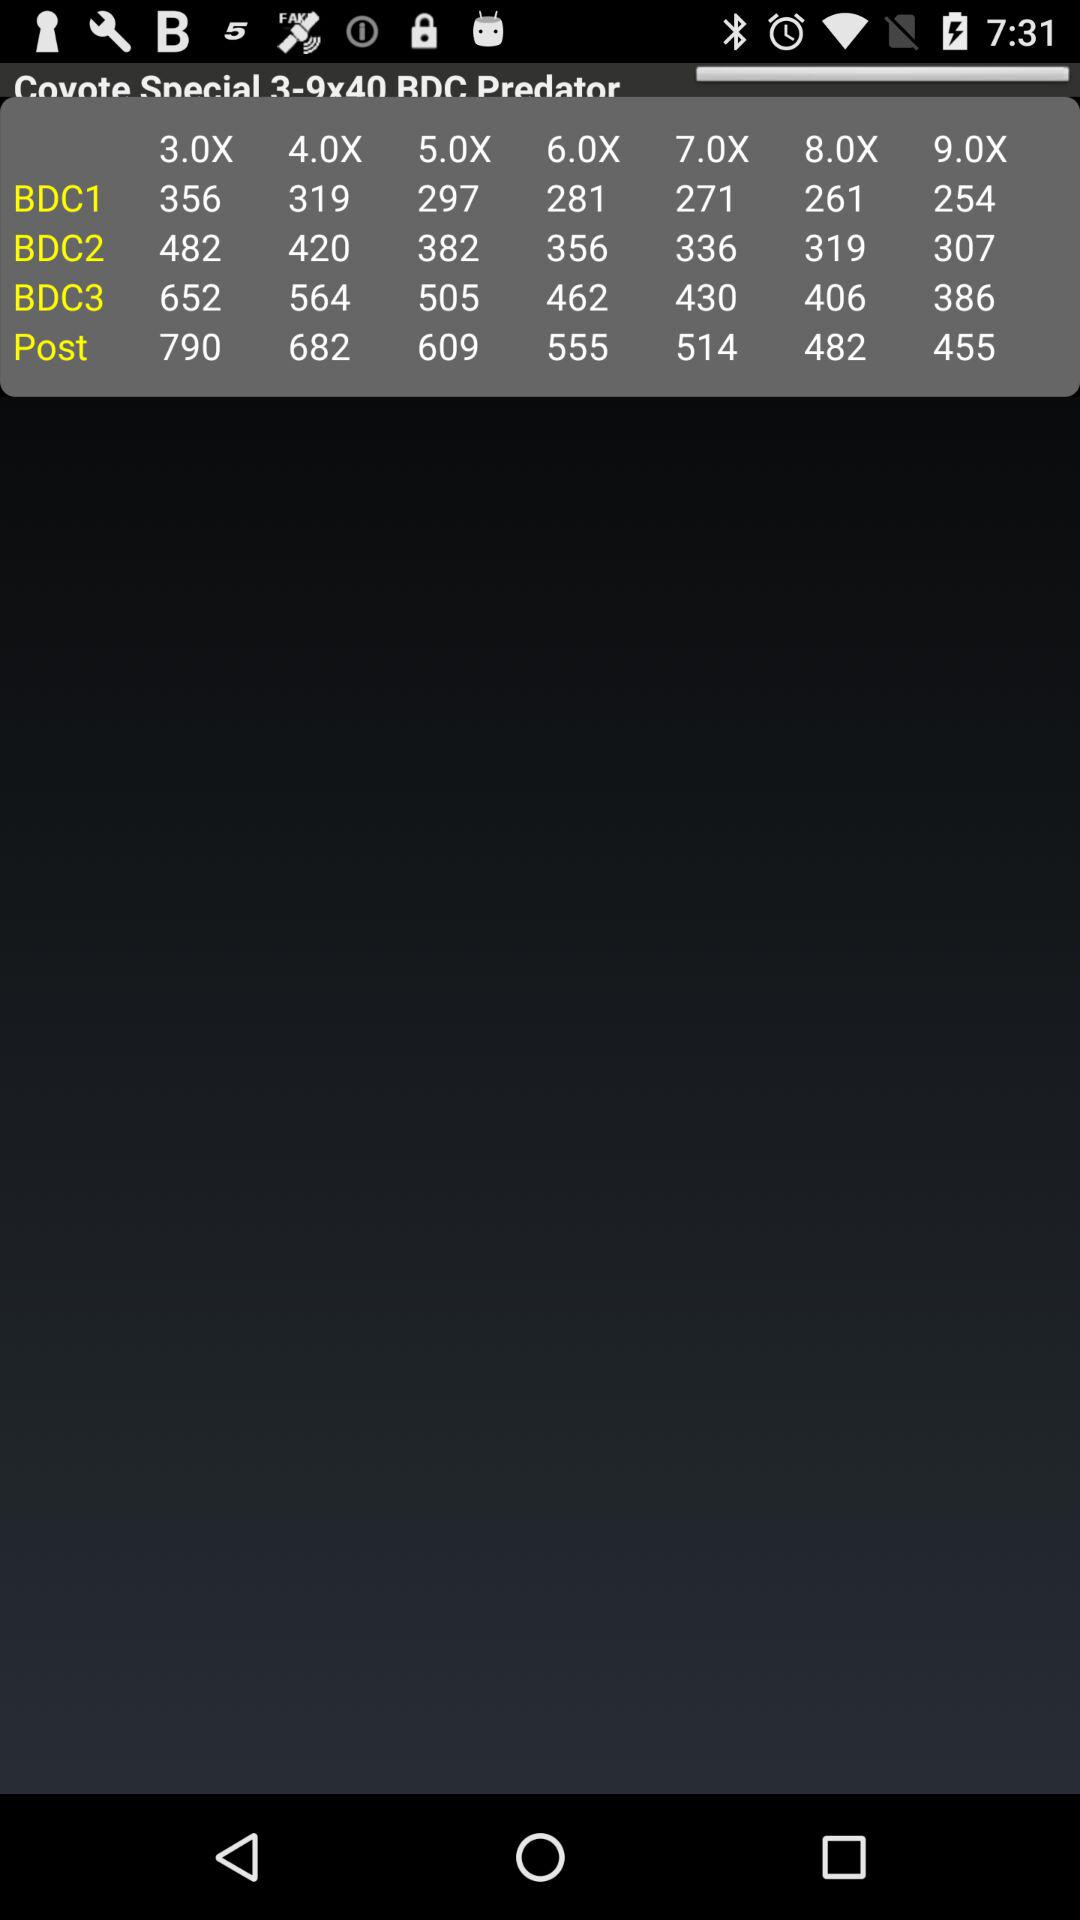How many BDCs are above 6x?
Answer the question using a single word or phrase. 3 